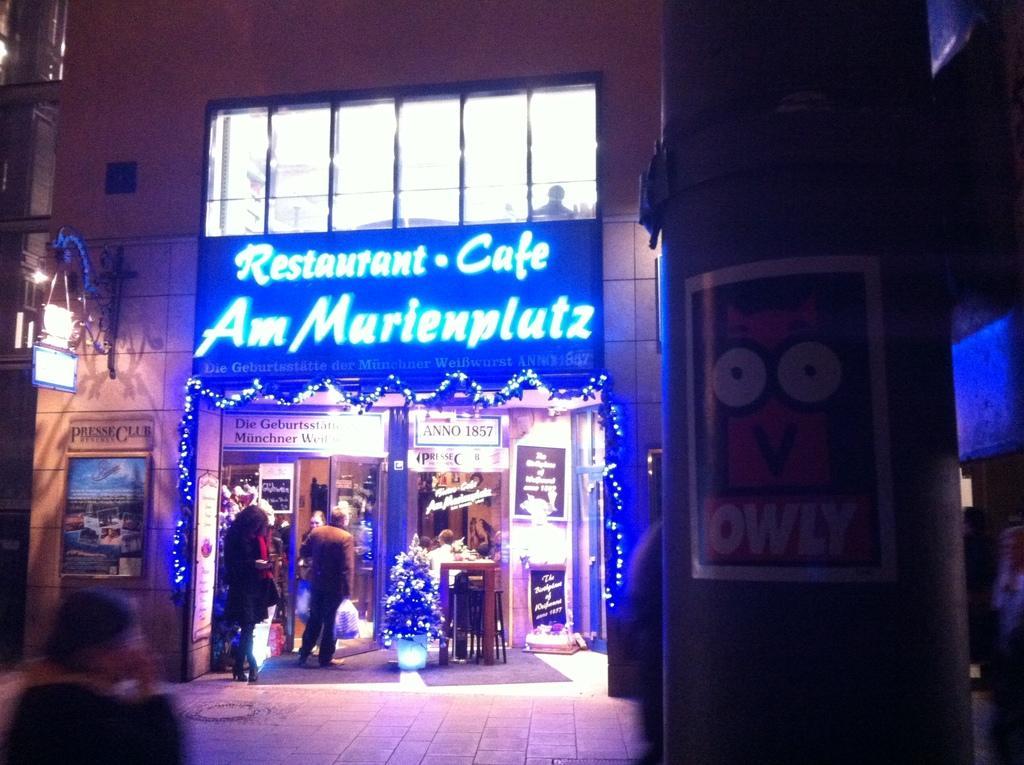Describe this image in one or two sentences. In this picture we can see the person who is standing near the door. On the right we can see the poster on the pole. At the top through the window we can see a man who is sitting on the chair. On the left there is a light on the building. 